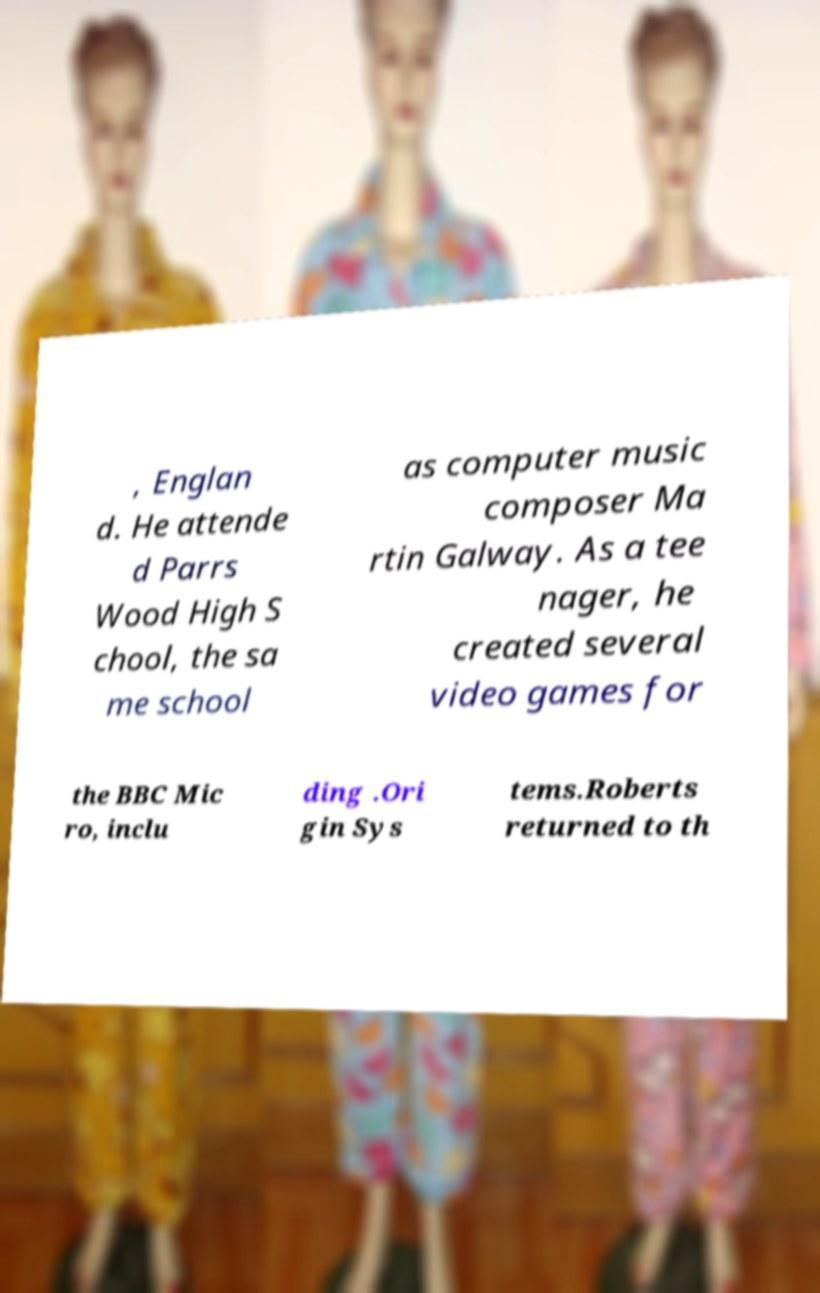Can you accurately transcribe the text from the provided image for me? , Englan d. He attende d Parrs Wood High S chool, the sa me school as computer music composer Ma rtin Galway. As a tee nager, he created several video games for the BBC Mic ro, inclu ding .Ori gin Sys tems.Roberts returned to th 